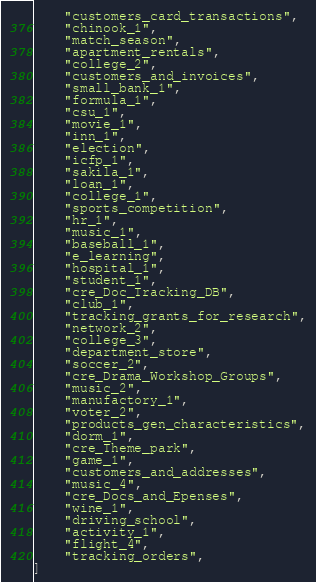<code> <loc_0><loc_0><loc_500><loc_500><_Python_>    "customers_card_transactions",
    "chinook_1",
    "match_season",
    "apartment_rentals",
    "college_2",
    "customers_and_invoices",
    "small_bank_1",
    "formula_1",
    "csu_1",
    "movie_1",
    "inn_1",
    "election",
    "icfp_1",
    "sakila_1",
    "loan_1",
    "college_1",
    "sports_competition",
    "hr_1",
    "music_1",
    "baseball_1",
    "e_learning",
    "hospital_1",
    "student_1",
    "cre_Doc_Tracking_DB",
    "club_1",
    "tracking_grants_for_research",
    "network_2",
    "college_3",
    "department_store",
    "soccer_2",
    "cre_Drama_Workshop_Groups",
    "music_2",
    "manufactory_1",
    "voter_2",
    "products_gen_characteristics",
    "dorm_1",
    "cre_Theme_park",
    "game_1",
    "customers_and_addresses",
    "music_4",
    "cre_Docs_and_Epenses",
    "wine_1",
    "driving_school",
    "activity_1",
    "flight_4",
    "tracking_orders",
]
</code> 